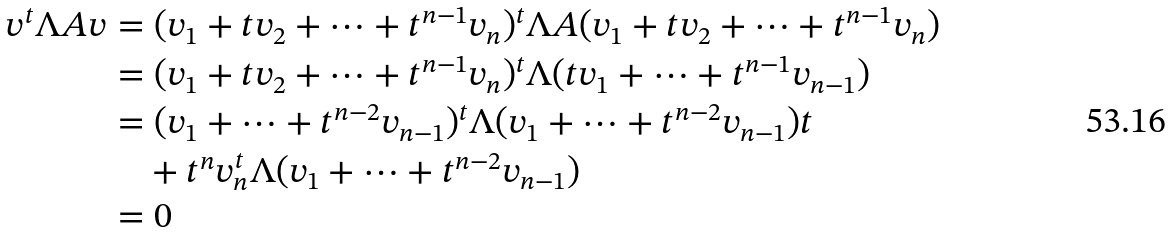Convert formula to latex. <formula><loc_0><loc_0><loc_500><loc_500>v ^ { t } \Lambda A v & = ( v _ { 1 } + t v _ { 2 } + \dots + t ^ { n - 1 } v _ { n } ) ^ { t } \Lambda A ( v _ { 1 } + t v _ { 2 } + \dots + t ^ { n - 1 } v _ { n } ) \\ & = ( v _ { 1 } + t v _ { 2 } + \dots + t ^ { n - 1 } v _ { n } ) ^ { t } \Lambda ( t v _ { 1 } + \dots + t ^ { n - 1 } v _ { n - 1 } ) \\ & = ( v _ { 1 } + \dots + t ^ { n - 2 } v _ { n - 1 } ) ^ { t } \Lambda ( v _ { 1 } + \dots + t ^ { n - 2 } v _ { n - 1 } ) t \\ & \quad + t ^ { n } v _ { n } ^ { t } \Lambda ( v _ { 1 } + \dots + t ^ { n - 2 } v _ { n - 1 } ) \\ & = 0</formula> 